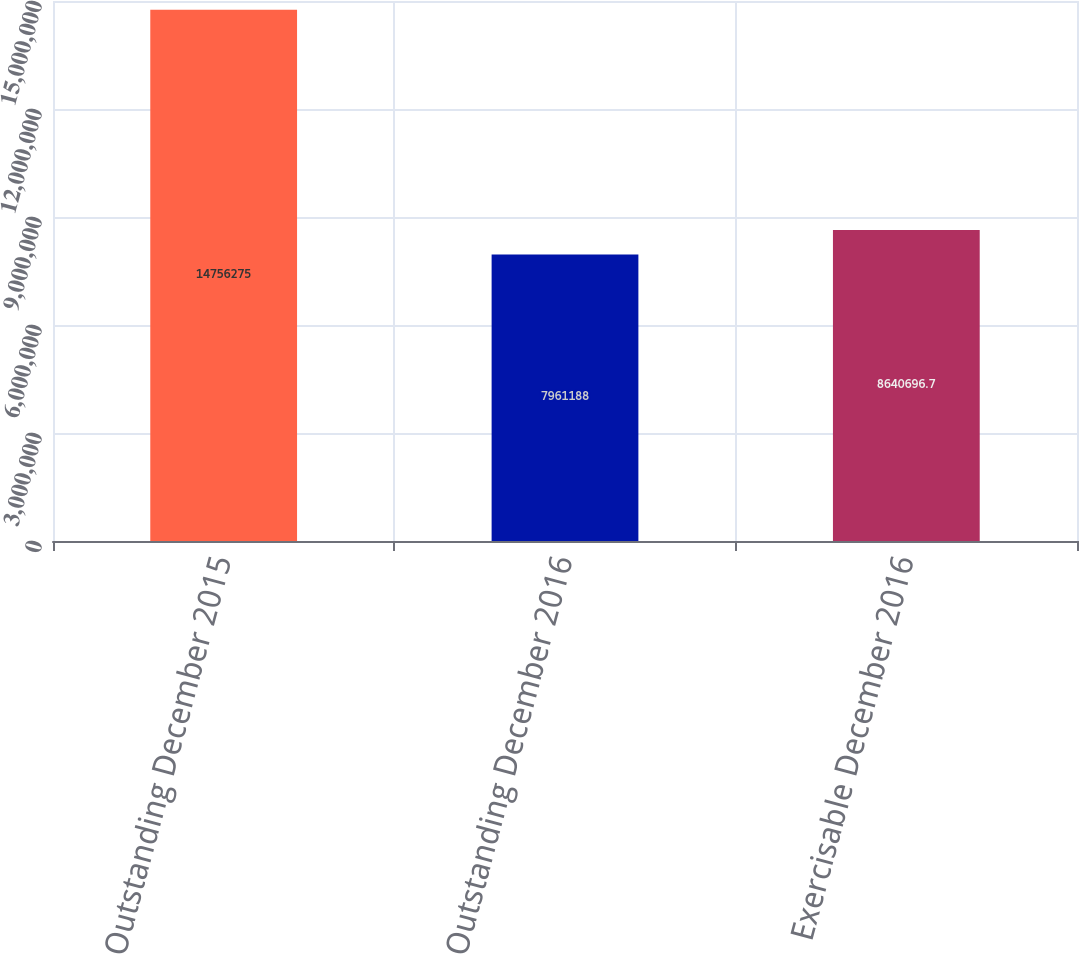Convert chart. <chart><loc_0><loc_0><loc_500><loc_500><bar_chart><fcel>Outstanding December 2015<fcel>Outstanding December 2016<fcel>Exercisable December 2016<nl><fcel>1.47563e+07<fcel>7.96119e+06<fcel>8.6407e+06<nl></chart> 